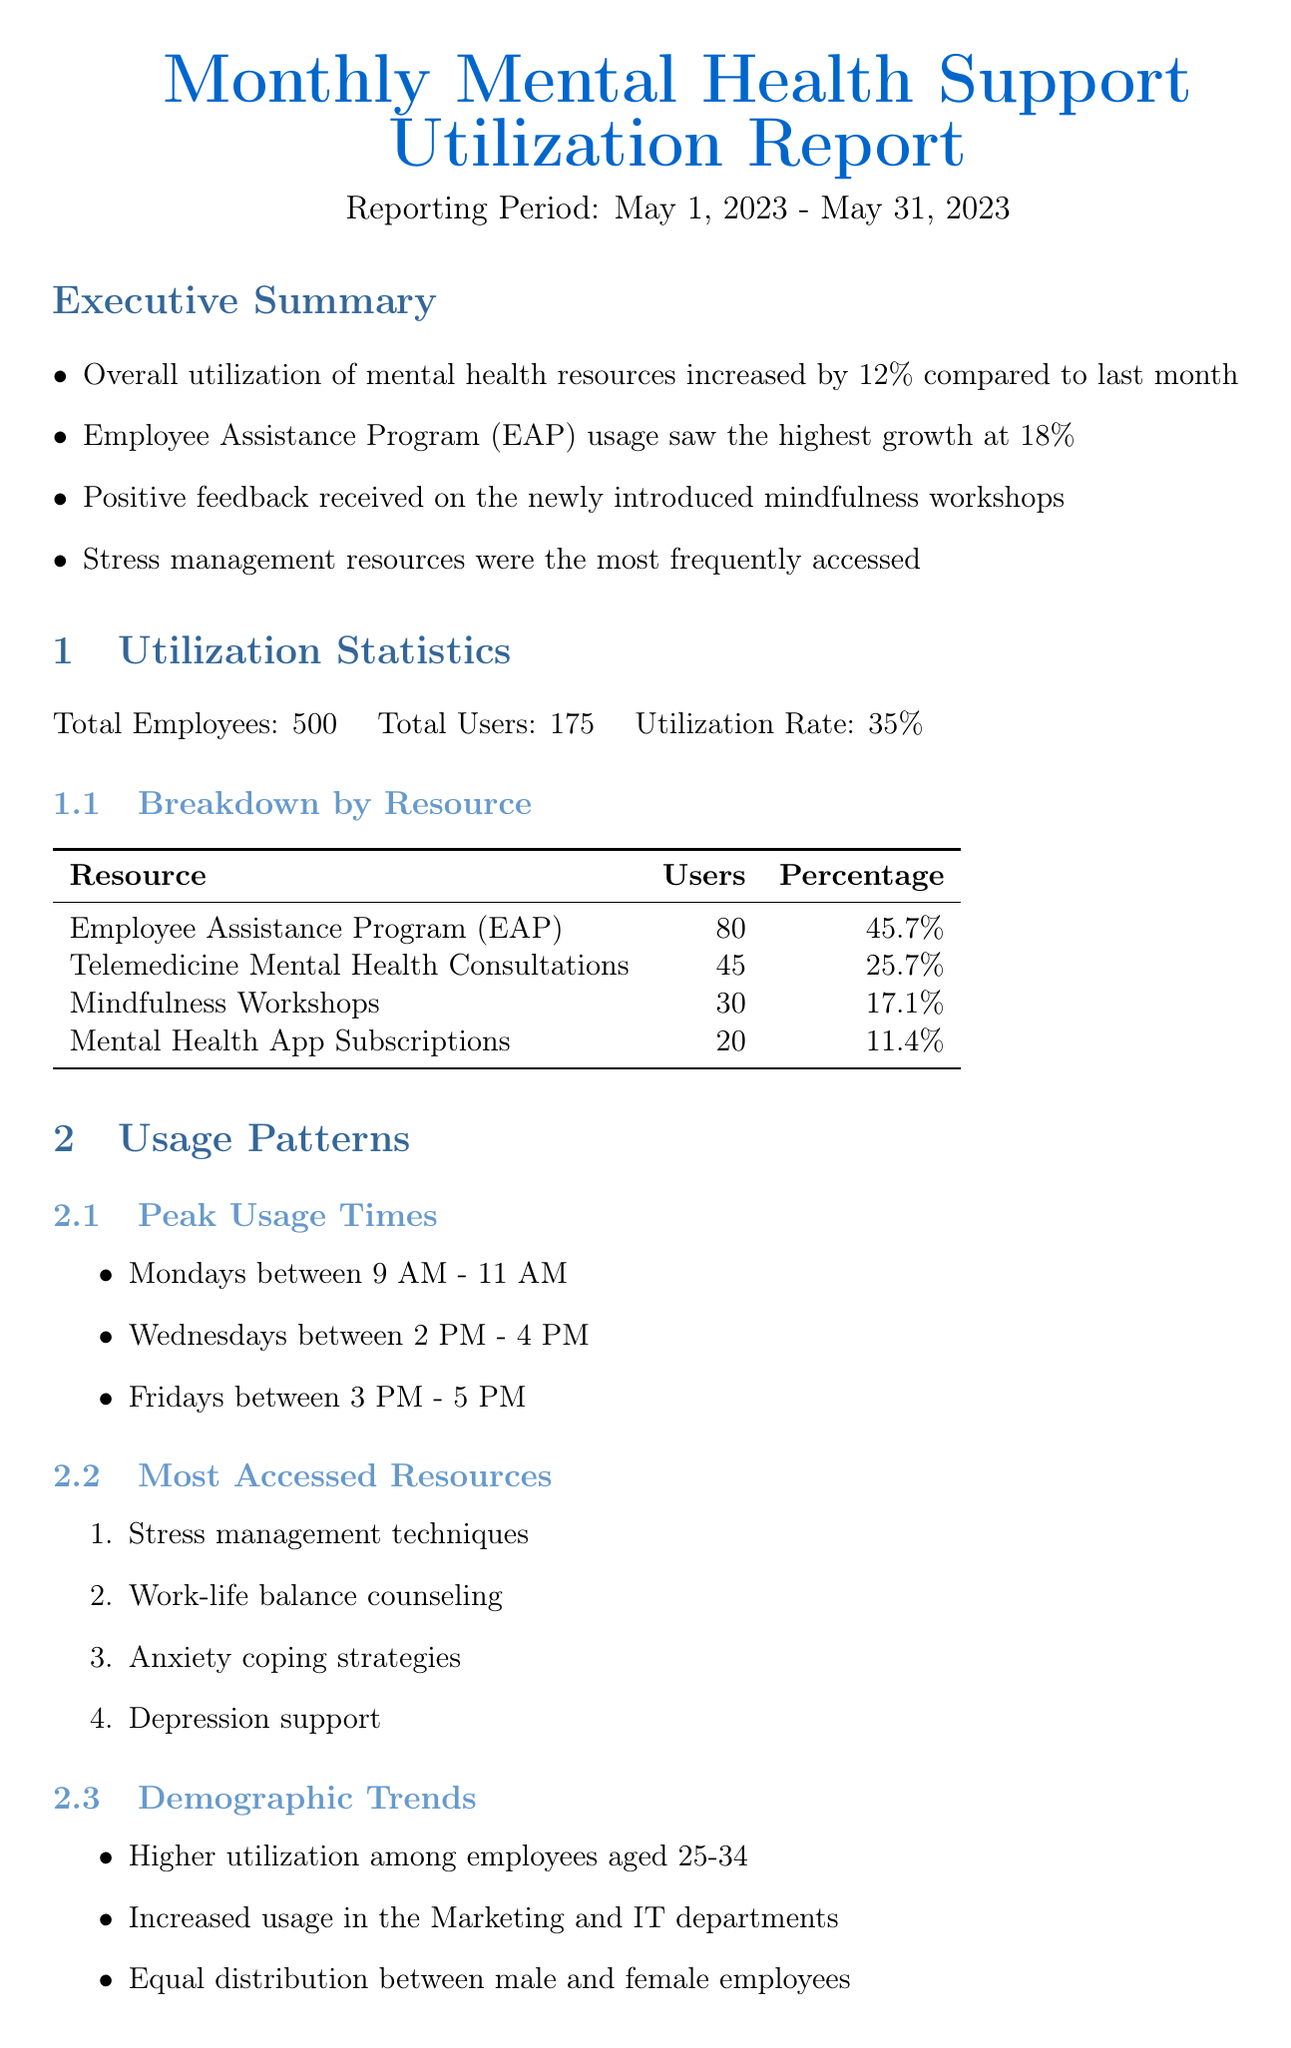What is the reporting period of the document? The reporting period is stated at the beginning of the document as May 1, 2023 - May 31, 2023.
Answer: May 1, 2023 - May 31, 2023 What was the increase in overall utilization of mental health resources? The document reports that the overall utilization of mental health resources increased by 12% compared to the last month.
Answer: 12% Which resource had the highest user percentage? The Employee Assistance Program (EAP) had 80 users, which is 45.7%, making it the highest.
Answer: Employee Assistance Program (EAP) What is the average satisfaction rating from employee feedback? The satisfaction rating is provided in the employee feedback section, which states a rating of 4.2 out of 5.
Answer: 4.2 What recommendation is made to increase awareness of resources? One recommendation is to increase awareness of available resources through targeted email campaigns.
Answer: Targeted email campaigns Which demographic had higher utilization of mental health resources? The document notes that higher utilization was among employees aged 25-34.
Answer: Employees aged 25-34 What was the most frequently accessed type of resource? According to the utilization statistics, stress management resources were the most frequently accessed.
Answer: Stress management resources What is the usage rate of the Headspace for Work app? The document states that the usage rate of the Headspace for Work app is 15% of employees actively using the app.
Answer: 15% What area for improvement was suggested for telemedicine consultations? The feedback suggested extending telemedicine consultation hours to accommodate different shifts.
Answer: Extend telemedicine consultation hours 